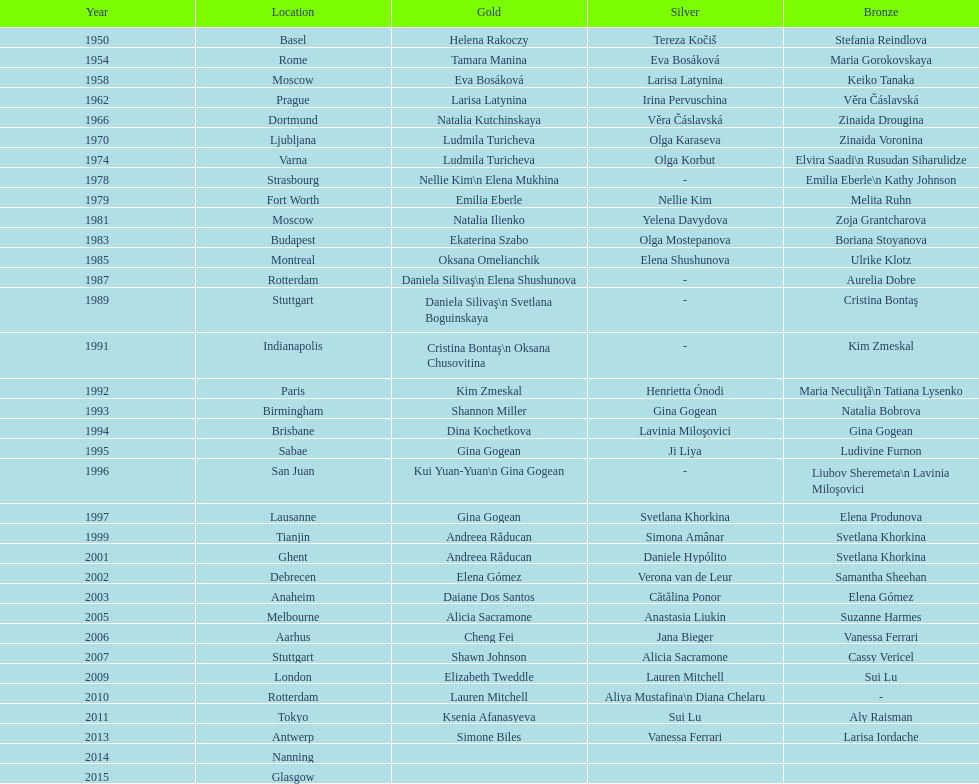Which two american rivals won consecutive floor exercise gold medals at the artistic gymnastics world championships in 1992 and 1993? Kim Zmeskal, Shannon Miller. Could you help me parse every detail presented in this table? {'header': ['Year', 'Location', 'Gold', 'Silver', 'Bronze'], 'rows': [['1950', 'Basel', 'Helena Rakoczy', 'Tereza Kočiš', 'Stefania Reindlova'], ['1954', 'Rome', 'Tamara Manina', 'Eva Bosáková', 'Maria Gorokovskaya'], ['1958', 'Moscow', 'Eva Bosáková', 'Larisa Latynina', 'Keiko Tanaka'], ['1962', 'Prague', 'Larisa Latynina', 'Irina Pervuschina', 'Věra Čáslavská'], ['1966', 'Dortmund', 'Natalia Kutchinskaya', 'Věra Čáslavská', 'Zinaida Drougina'], ['1970', 'Ljubljana', 'Ludmila Turicheva', 'Olga Karaseva', 'Zinaida Voronina'], ['1974', 'Varna', 'Ludmila Turicheva', 'Olga Korbut', 'Elvira Saadi\\n Rusudan Siharulidze'], ['1978', 'Strasbourg', 'Nellie Kim\\n Elena Mukhina', '-', 'Emilia Eberle\\n Kathy Johnson'], ['1979', 'Fort Worth', 'Emilia Eberle', 'Nellie Kim', 'Melita Ruhn'], ['1981', 'Moscow', 'Natalia Ilienko', 'Yelena Davydova', 'Zoja Grantcharova'], ['1983', 'Budapest', 'Ekaterina Szabo', 'Olga Mostepanova', 'Boriana Stoyanova'], ['1985', 'Montreal', 'Oksana Omelianchik', 'Elena Shushunova', 'Ulrike Klotz'], ['1987', 'Rotterdam', 'Daniela Silivaş\\n Elena Shushunova', '-', 'Aurelia Dobre'], ['1989', 'Stuttgart', 'Daniela Silivaş\\n Svetlana Boguinskaya', '-', 'Cristina Bontaş'], ['1991', 'Indianapolis', 'Cristina Bontaş\\n Oksana Chusovitina', '-', 'Kim Zmeskal'], ['1992', 'Paris', 'Kim Zmeskal', 'Henrietta Ónodi', 'Maria Neculiţă\\n Tatiana Lysenko'], ['1993', 'Birmingham', 'Shannon Miller', 'Gina Gogean', 'Natalia Bobrova'], ['1994', 'Brisbane', 'Dina Kochetkova', 'Lavinia Miloşovici', 'Gina Gogean'], ['1995', 'Sabae', 'Gina Gogean', 'Ji Liya', 'Ludivine Furnon'], ['1996', 'San Juan', 'Kui Yuan-Yuan\\n Gina Gogean', '-', 'Liubov Sheremeta\\n Lavinia Miloşovici'], ['1997', 'Lausanne', 'Gina Gogean', 'Svetlana Khorkina', 'Elena Produnova'], ['1999', 'Tianjin', 'Andreea Răducan', 'Simona Amânar', 'Svetlana Khorkina'], ['2001', 'Ghent', 'Andreea Răducan', 'Daniele Hypólito', 'Svetlana Khorkina'], ['2002', 'Debrecen', 'Elena Gómez', 'Verona van de Leur', 'Samantha Sheehan'], ['2003', 'Anaheim', 'Daiane Dos Santos', 'Cătălina Ponor', 'Elena Gómez'], ['2005', 'Melbourne', 'Alicia Sacramone', 'Anastasia Liukin', 'Suzanne Harmes'], ['2006', 'Aarhus', 'Cheng Fei', 'Jana Bieger', 'Vanessa Ferrari'], ['2007', 'Stuttgart', 'Shawn Johnson', 'Alicia Sacramone', 'Cassy Vericel'], ['2009', 'London', 'Elizabeth Tweddle', 'Lauren Mitchell', 'Sui Lu'], ['2010', 'Rotterdam', 'Lauren Mitchell', 'Aliya Mustafina\\n Diana Chelaru', '-'], ['2011', 'Tokyo', 'Ksenia Afanasyeva', 'Sui Lu', 'Aly Raisman'], ['2013', 'Antwerp', 'Simone Biles', 'Vanessa Ferrari', 'Larisa Iordache'], ['2014', 'Nanning', '', '', ''], ['2015', 'Glasgow', '', '', '']]} 